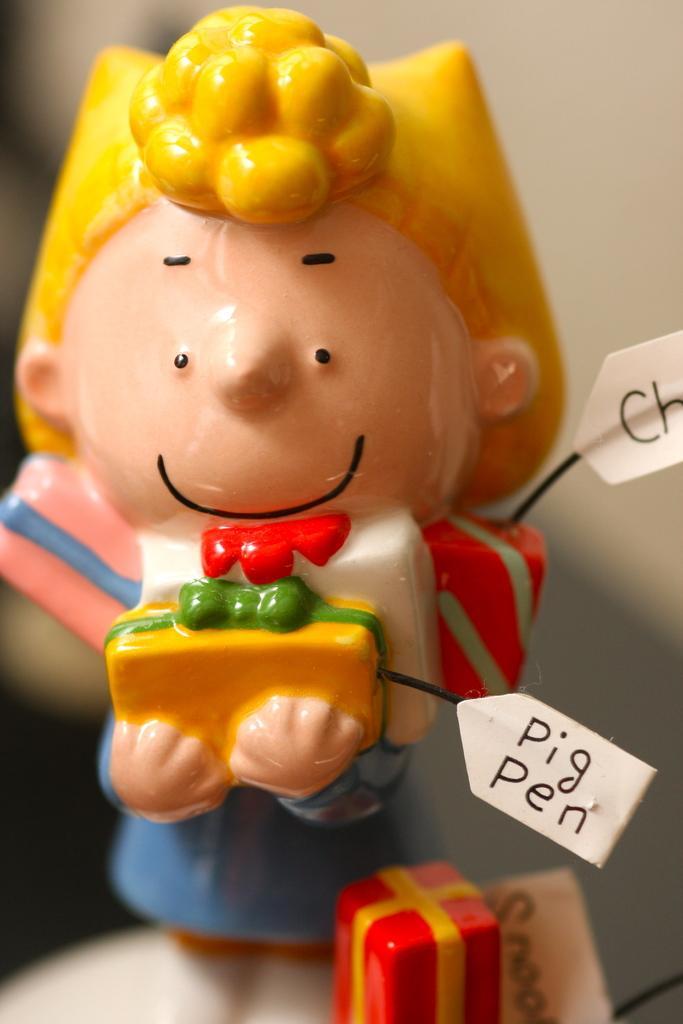In one or two sentences, can you explain what this image depicts? In the picture I can see a toy, here I can see some text and the surroundings of the image is slightly blurred. 